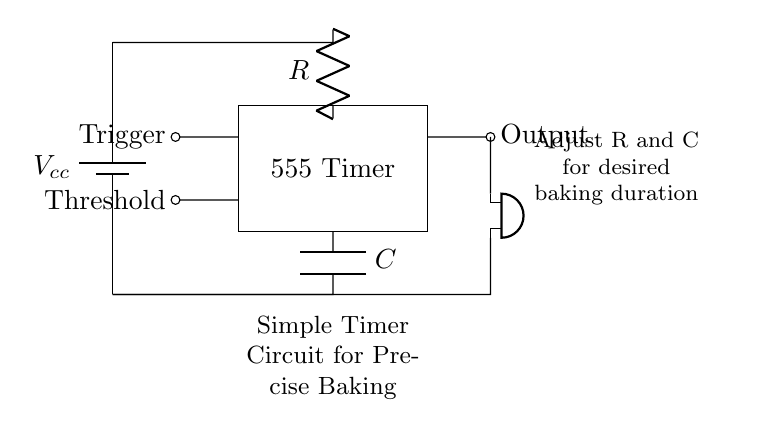What is the main component used for timing? The main component for timing is the capacitor, which stores charge and influences the duration for which the output remains high. In this circuit, it is labeled as "C."
Answer: C What component triggers the timer? The timer is triggered by the "Trigger" pin from the 555 Timer IC, which initiates the timing cycle when it receives a low voltage signal.
Answer: Trigger Which component indicates the end of the timer? The buzzer indicates the end of the timing cycle by sounding an alert when the output signal from the timer goes high.
Answer: Buzzer What affects the baking duration in this circuit? The baking duration is affected by the values of the resistor and capacitor, labeled as "R" and "C" respectively, which can be adjusted to change timing.
Answer: R and C How many terminals does the 555 Timer have? The 555 Timer IC in this circuit has eight terminals, as it is a standard configuration for this popular timer IC.
Answer: Eight What is the power supply voltage used? The circuit is powered by a voltage source indicated by "Vcc," which is typically between 5V to 15V for a 555 Timer, though the exact voltage is not specified here.
Answer: Vcc What happens when the threshold is reached? When the threshold pin of the timer reaches a certain voltage, the output goes low, effectively indicating the end of the timing period for the baking process.
Answer: Output goes low 